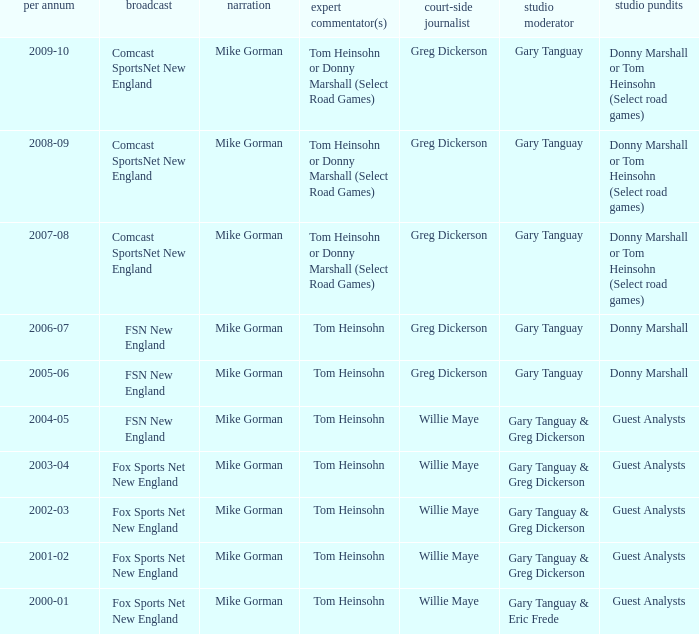WHich Color commentatorhas a Studio host of gary tanguay & eric frede? Tom Heinsohn. 